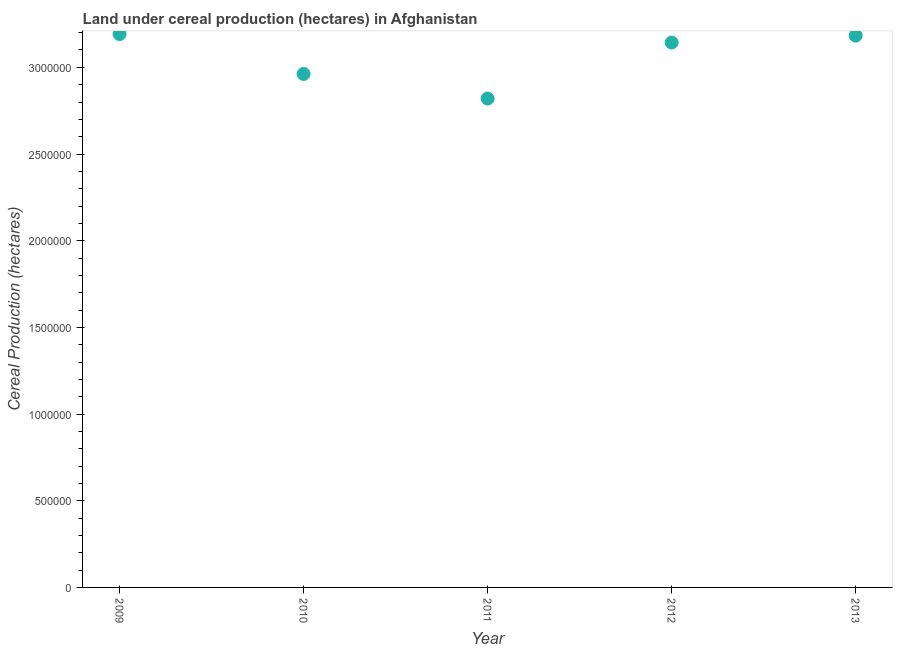What is the land under cereal production in 2010?
Your answer should be very brief. 2.96e+06. Across all years, what is the maximum land under cereal production?
Offer a very short reply. 3.19e+06. Across all years, what is the minimum land under cereal production?
Ensure brevity in your answer.  2.82e+06. What is the sum of the land under cereal production?
Your answer should be very brief. 1.53e+07. What is the difference between the land under cereal production in 2010 and 2013?
Ensure brevity in your answer.  -2.21e+05. What is the average land under cereal production per year?
Ensure brevity in your answer.  3.06e+06. What is the median land under cereal production?
Make the answer very short. 3.14e+06. In how many years, is the land under cereal production greater than 1200000 hectares?
Ensure brevity in your answer.  5. What is the ratio of the land under cereal production in 2009 to that in 2013?
Provide a short and direct response. 1. What is the difference between the highest and the second highest land under cereal production?
Provide a succinct answer. 9078. What is the difference between the highest and the lowest land under cereal production?
Offer a very short reply. 3.72e+05. How many years are there in the graph?
Make the answer very short. 5. What is the difference between two consecutive major ticks on the Y-axis?
Your answer should be very brief. 5.00e+05. Are the values on the major ticks of Y-axis written in scientific E-notation?
Keep it short and to the point. No. Does the graph contain any zero values?
Your answer should be compact. No. Does the graph contain grids?
Provide a short and direct response. No. What is the title of the graph?
Offer a terse response. Land under cereal production (hectares) in Afghanistan. What is the label or title of the Y-axis?
Your response must be concise. Cereal Production (hectares). What is the Cereal Production (hectares) in 2009?
Ensure brevity in your answer.  3.19e+06. What is the Cereal Production (hectares) in 2010?
Provide a short and direct response. 2.96e+06. What is the Cereal Production (hectares) in 2011?
Make the answer very short. 2.82e+06. What is the Cereal Production (hectares) in 2012?
Offer a terse response. 3.14e+06. What is the Cereal Production (hectares) in 2013?
Offer a very short reply. 3.18e+06. What is the difference between the Cereal Production (hectares) in 2009 and 2010?
Your response must be concise. 2.30e+05. What is the difference between the Cereal Production (hectares) in 2009 and 2011?
Provide a short and direct response. 3.72e+05. What is the difference between the Cereal Production (hectares) in 2009 and 2012?
Your answer should be compact. 4.90e+04. What is the difference between the Cereal Production (hectares) in 2009 and 2013?
Ensure brevity in your answer.  9078. What is the difference between the Cereal Production (hectares) in 2010 and 2011?
Your response must be concise. 1.42e+05. What is the difference between the Cereal Production (hectares) in 2010 and 2012?
Ensure brevity in your answer.  -1.81e+05. What is the difference between the Cereal Production (hectares) in 2010 and 2013?
Your answer should be very brief. -2.21e+05. What is the difference between the Cereal Production (hectares) in 2011 and 2012?
Offer a very short reply. -3.23e+05. What is the difference between the Cereal Production (hectares) in 2011 and 2013?
Your response must be concise. -3.63e+05. What is the difference between the Cereal Production (hectares) in 2012 and 2013?
Your answer should be compact. -3.99e+04. What is the ratio of the Cereal Production (hectares) in 2009 to that in 2010?
Your response must be concise. 1.08. What is the ratio of the Cereal Production (hectares) in 2009 to that in 2011?
Your answer should be very brief. 1.13. What is the ratio of the Cereal Production (hectares) in 2009 to that in 2012?
Your response must be concise. 1.02. What is the ratio of the Cereal Production (hectares) in 2010 to that in 2012?
Your answer should be very brief. 0.94. What is the ratio of the Cereal Production (hectares) in 2010 to that in 2013?
Your answer should be compact. 0.93. What is the ratio of the Cereal Production (hectares) in 2011 to that in 2012?
Provide a short and direct response. 0.9. What is the ratio of the Cereal Production (hectares) in 2011 to that in 2013?
Your answer should be very brief. 0.89. 